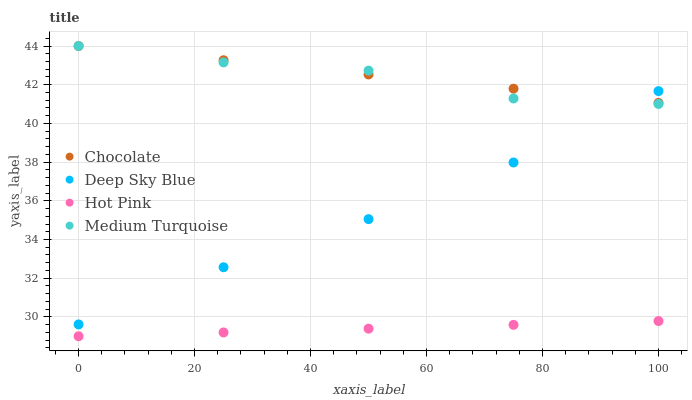Does Hot Pink have the minimum area under the curve?
Answer yes or no. Yes. Does Chocolate have the maximum area under the curve?
Answer yes or no. Yes. Does Medium Turquoise have the minimum area under the curve?
Answer yes or no. No. Does Medium Turquoise have the maximum area under the curve?
Answer yes or no. No. Is Hot Pink the smoothest?
Answer yes or no. Yes. Is Medium Turquoise the roughest?
Answer yes or no. Yes. Is Deep Sky Blue the smoothest?
Answer yes or no. No. Is Deep Sky Blue the roughest?
Answer yes or no. No. Does Hot Pink have the lowest value?
Answer yes or no. Yes. Does Medium Turquoise have the lowest value?
Answer yes or no. No. Does Chocolate have the highest value?
Answer yes or no. Yes. Does Deep Sky Blue have the highest value?
Answer yes or no. No. Is Hot Pink less than Deep Sky Blue?
Answer yes or no. Yes. Is Deep Sky Blue greater than Hot Pink?
Answer yes or no. Yes. Does Medium Turquoise intersect Deep Sky Blue?
Answer yes or no. Yes. Is Medium Turquoise less than Deep Sky Blue?
Answer yes or no. No. Is Medium Turquoise greater than Deep Sky Blue?
Answer yes or no. No. Does Hot Pink intersect Deep Sky Blue?
Answer yes or no. No. 